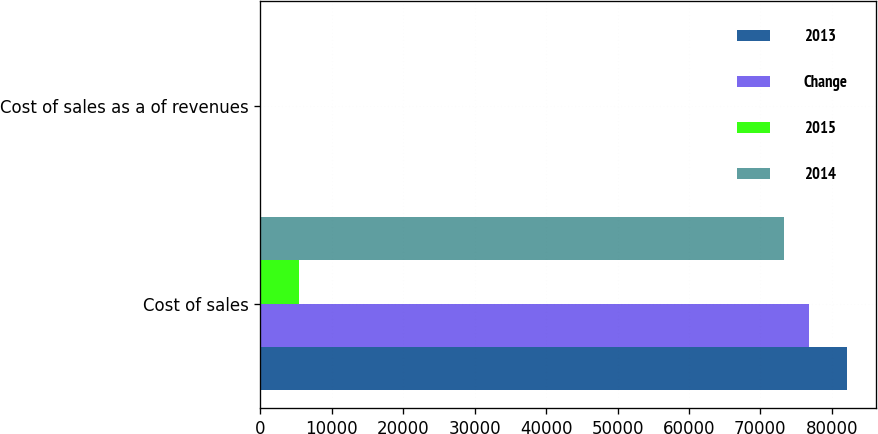<chart> <loc_0><loc_0><loc_500><loc_500><stacked_bar_chart><ecel><fcel>Cost of sales<fcel>Cost of sales as a of revenues<nl><fcel>2013<fcel>82088<fcel>85.4<nl><fcel>Change<fcel>76752<fcel>84.6<nl><fcel>2015<fcel>5336<fcel>0.8<nl><fcel>2014<fcel>73268<fcel>84.6<nl></chart> 